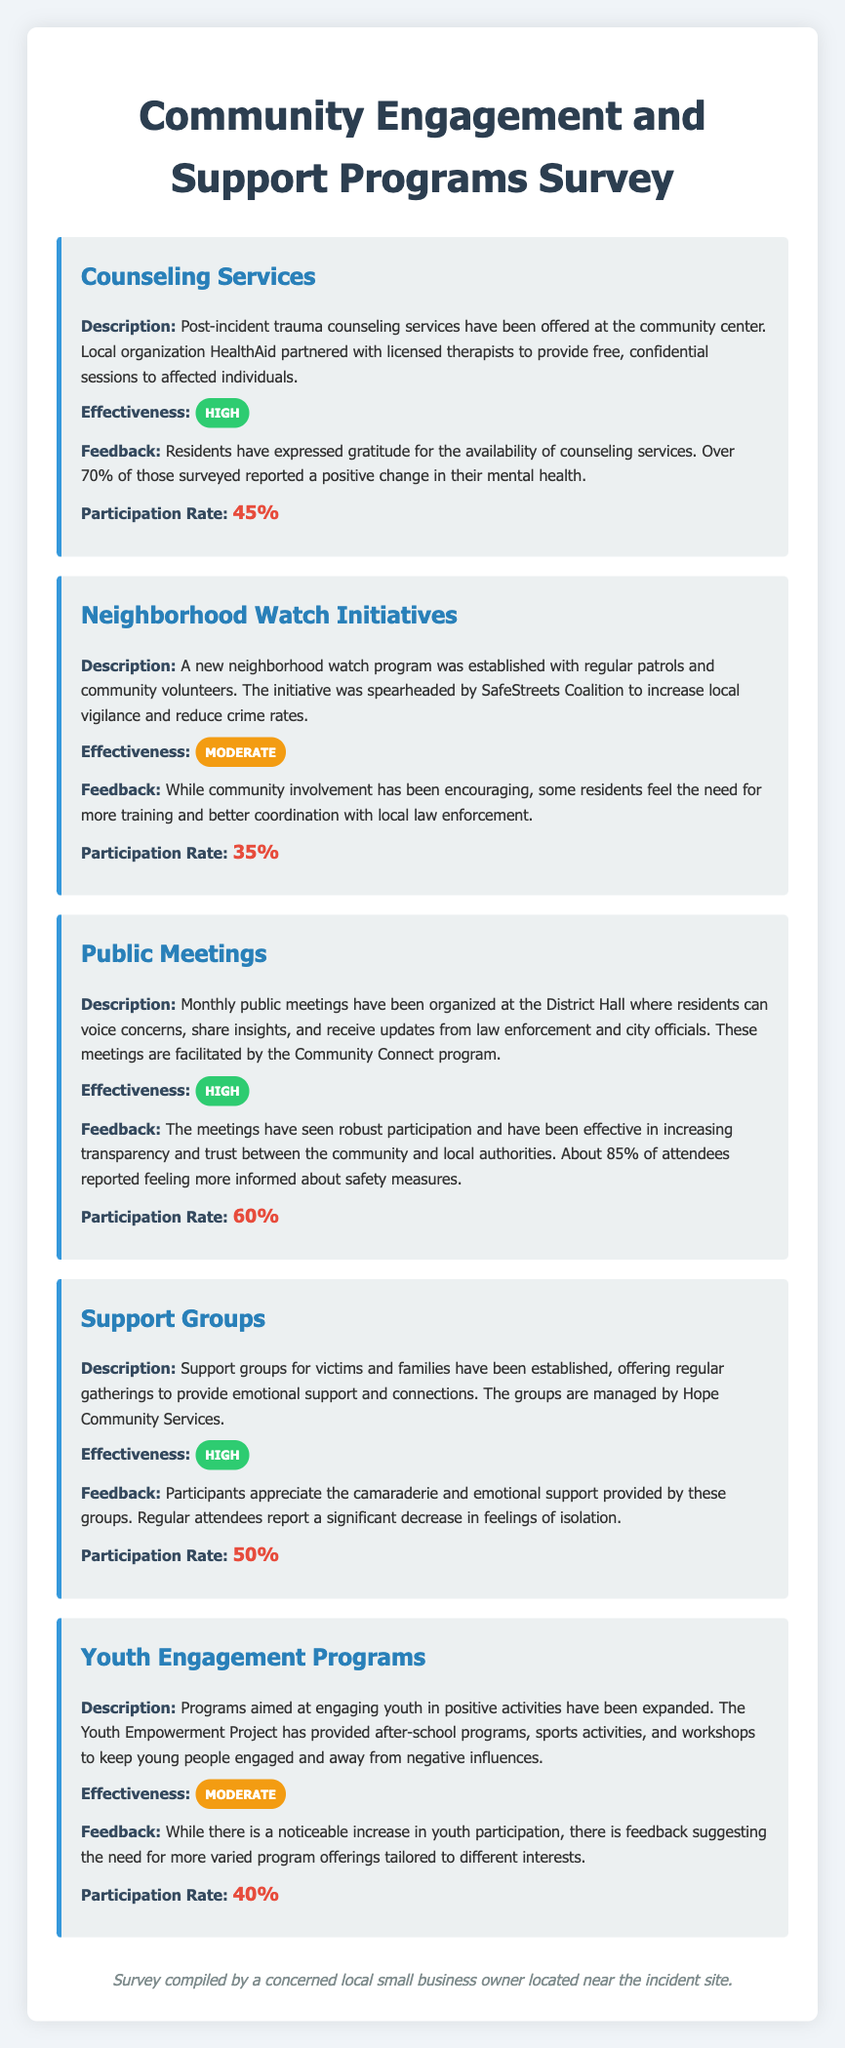What is the participation rate for Counseling Services? The participation rate for Counseling Services is clearly stated in the document.
Answer: 45% What organization partnered for Counseling Services? The document mentions that HealthAid partnered with licensed therapists for Counseling Services.
Answer: HealthAid What is the effectiveness rating for Neighborhood Watch Initiatives? The document specifies that Neighborhood Watch Initiatives have a moderate effectiveness rating.
Answer: Moderate What percentage of attendees reported feeling more informed after Public Meetings? The document states that about 85% of attendees reported feeling more informed about safety measures at Public Meetings.
Answer: 85% What type of support is provided by Hope Community Services? The document describes that Hope Community Services manages support groups offering emotional support.
Answer: Emotional support How many community engagement initiatives are detailed in the document? The document lists five different community engagement initiatives under the survey.
Answer: Five What feedback was received regarding the Youth Engagement Programs? The document indicates that feedback suggests the need for more varied program offerings tailored to different interests.
Answer: More varied program offerings Which initiative received the highest effectiveness rating? The document reveals that both Counseling Services and Support Groups received high effectiveness ratings.
Answer: Counseling Services and Support Groups What is the participation rate for Public Meetings? The participation rate for Public Meetings is explicitly provided in the document.
Answer: 60% 